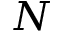Convert formula to latex. <formula><loc_0><loc_0><loc_500><loc_500>N</formula> 